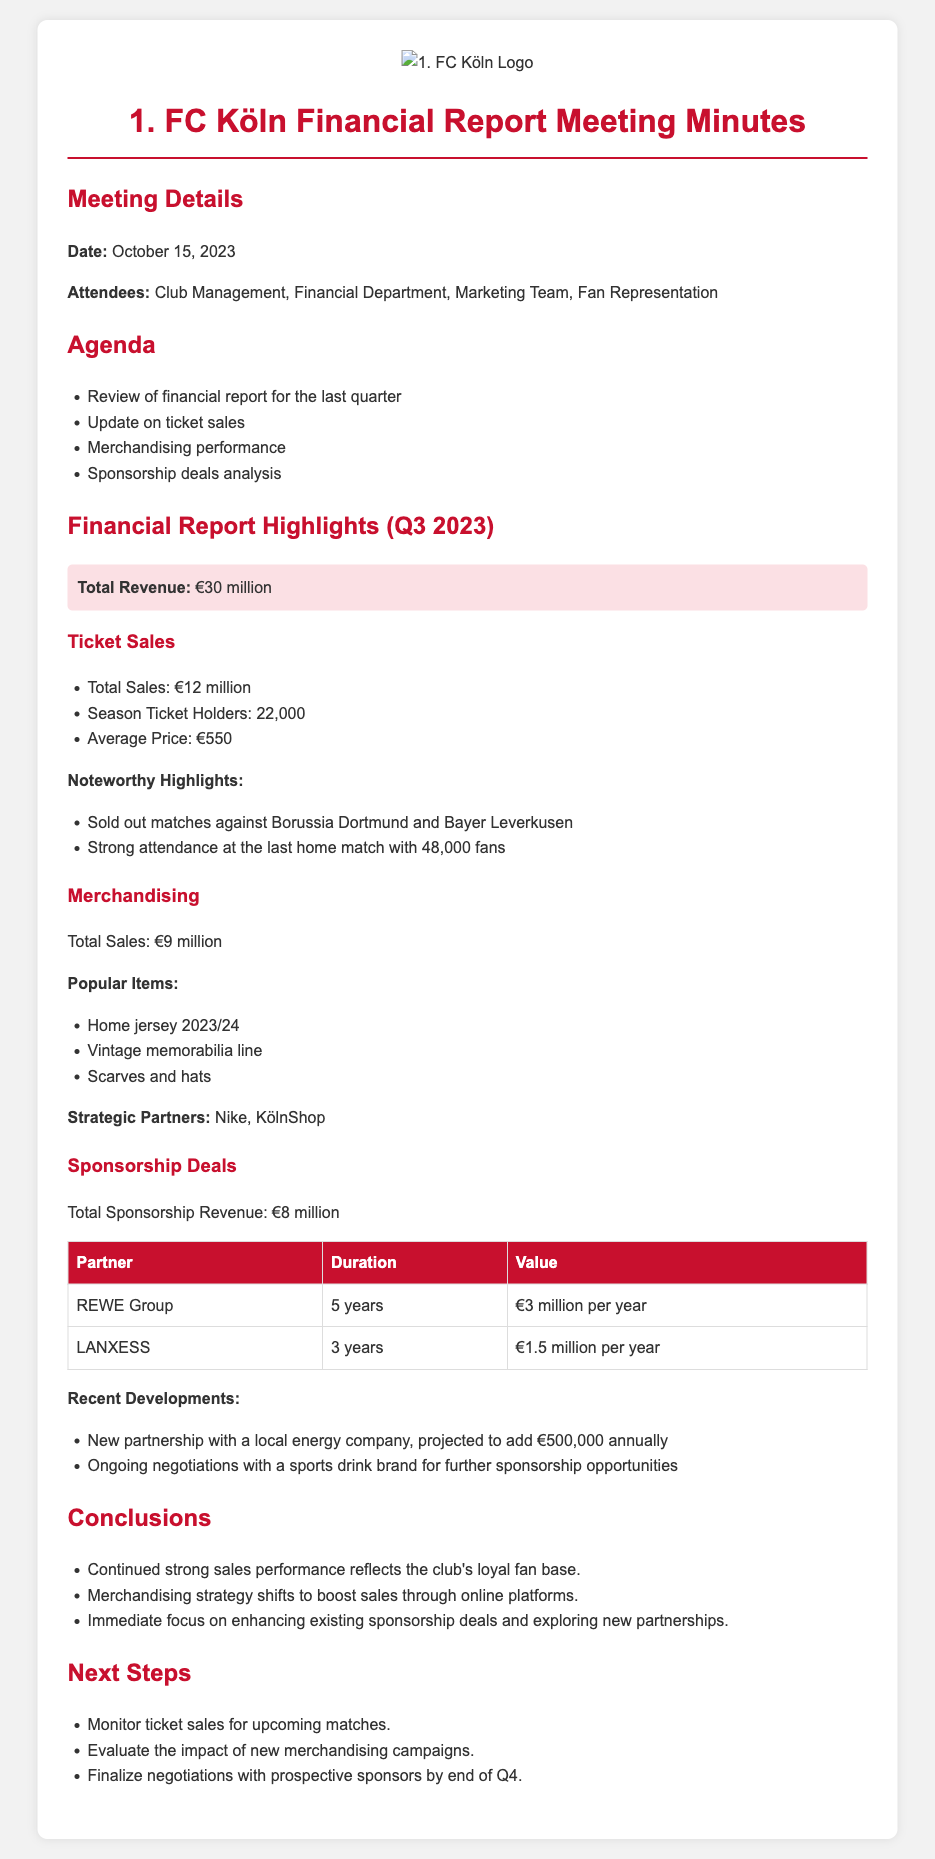What is the date of the meeting? The date of the meeting is provided in the Meeting Details section, which states October 15, 2023.
Answer: October 15, 2023 What was the total ticket sales revenue? The financial report outlines the total sales from ticket sales, which is indicated as €12 million.
Answer: €12 million How many season ticket holders does 1. FC Köln have? The number of season ticket holders is specified in the Ticket Sales section as 22,000.
Answer: 22,000 What are the popular merchandising items? The document lists specific items under Popular Items in the Merchandising section including home jersey, vintage memorabilia line, and scarves and hats.
Answer: Home jersey 2023/24, Vintage memorabilia line, Scarves and hats What is the total sponsorship revenue? The total sponsorship revenue is stated in the Sponsorship Deals section as €8 million.
Answer: €8 million What recent development is highlighted in the sponsorship deals? The document mentions a new partnership with a local energy company, which is a recent development in the sponsorship deals section.
Answer: New partnership with a local energy company What strategic shift is noted for merchandising? The Conclusion section mentions that the merchandising strategy shifts to boost sales through online platforms as a key point.
Answer: Boost sales through online platforms How many attendees were at the meeting? The attendees are listed in the Meeting Details section, consisting of Club Management, Financial Department, Marketing Team, and Fan Representation.
Answer: Club Management, Financial Department, Marketing Team, Fan Representation 